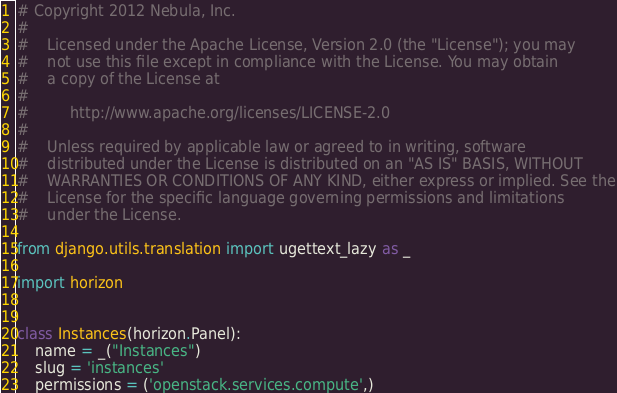<code> <loc_0><loc_0><loc_500><loc_500><_Python_># Copyright 2012 Nebula, Inc.
#
#    Licensed under the Apache License, Version 2.0 (the "License"); you may
#    not use this file except in compliance with the License. You may obtain
#    a copy of the License at
#
#         http://www.apache.org/licenses/LICENSE-2.0
#
#    Unless required by applicable law or agreed to in writing, software
#    distributed under the License is distributed on an "AS IS" BASIS, WITHOUT
#    WARRANTIES OR CONDITIONS OF ANY KIND, either express or implied. See the
#    License for the specific language governing permissions and limitations
#    under the License.

from django.utils.translation import ugettext_lazy as _

import horizon


class Instances(horizon.Panel):
    name = _("Instances")
    slug = 'instances'
    permissions = ('openstack.services.compute',)
</code> 